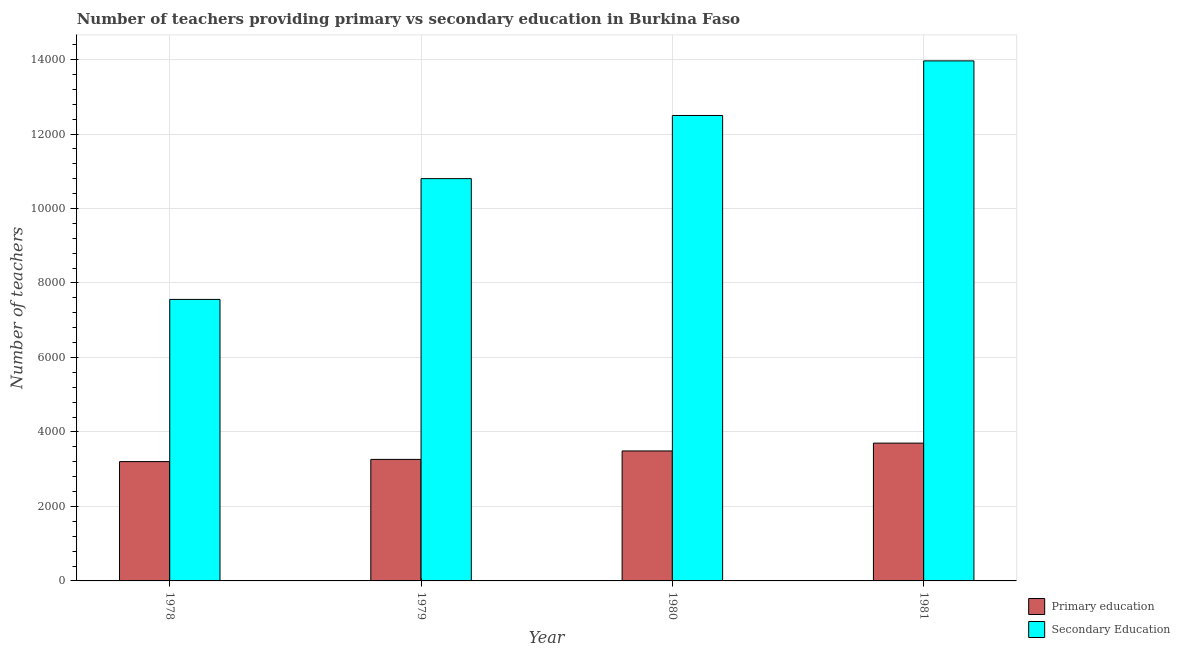Are the number of bars per tick equal to the number of legend labels?
Provide a succinct answer. Yes. How many bars are there on the 1st tick from the left?
Give a very brief answer. 2. What is the label of the 2nd group of bars from the left?
Your answer should be very brief. 1979. What is the number of secondary teachers in 1980?
Provide a succinct answer. 1.25e+04. Across all years, what is the maximum number of primary teachers?
Provide a succinct answer. 3700. Across all years, what is the minimum number of secondary teachers?
Keep it short and to the point. 7559. In which year was the number of primary teachers maximum?
Ensure brevity in your answer.  1981. In which year was the number of primary teachers minimum?
Offer a very short reply. 1978. What is the total number of primary teachers in the graph?
Make the answer very short. 1.37e+04. What is the difference between the number of primary teachers in 1980 and that in 1981?
Ensure brevity in your answer.  -210. What is the difference between the number of primary teachers in 1978 and the number of secondary teachers in 1981?
Ensure brevity in your answer.  -496. What is the average number of primary teachers per year?
Your response must be concise. 3414.25. What is the ratio of the number of secondary teachers in 1980 to that in 1981?
Your response must be concise. 0.9. Is the number of primary teachers in 1980 less than that in 1981?
Ensure brevity in your answer.  Yes. Is the difference between the number of primary teachers in 1980 and 1981 greater than the difference between the number of secondary teachers in 1980 and 1981?
Ensure brevity in your answer.  No. What is the difference between the highest and the second highest number of secondary teachers?
Provide a succinct answer. 1466. What is the difference between the highest and the lowest number of primary teachers?
Offer a terse response. 496. What does the 1st bar from the left in 1978 represents?
Your answer should be compact. Primary education. What does the 1st bar from the right in 1981 represents?
Offer a terse response. Secondary Education. How many bars are there?
Keep it short and to the point. 8. Are all the bars in the graph horizontal?
Provide a short and direct response. No. How many years are there in the graph?
Make the answer very short. 4. Are the values on the major ticks of Y-axis written in scientific E-notation?
Keep it short and to the point. No. What is the title of the graph?
Give a very brief answer. Number of teachers providing primary vs secondary education in Burkina Faso. Does "Net savings(excluding particulate emission damage)" appear as one of the legend labels in the graph?
Give a very brief answer. No. What is the label or title of the Y-axis?
Give a very brief answer. Number of teachers. What is the Number of teachers of Primary education in 1978?
Ensure brevity in your answer.  3204. What is the Number of teachers of Secondary Education in 1978?
Offer a very short reply. 7559. What is the Number of teachers in Primary education in 1979?
Ensure brevity in your answer.  3263. What is the Number of teachers in Secondary Education in 1979?
Your response must be concise. 1.08e+04. What is the Number of teachers in Primary education in 1980?
Offer a terse response. 3490. What is the Number of teachers of Secondary Education in 1980?
Your response must be concise. 1.25e+04. What is the Number of teachers of Primary education in 1981?
Give a very brief answer. 3700. What is the Number of teachers in Secondary Education in 1981?
Give a very brief answer. 1.40e+04. Across all years, what is the maximum Number of teachers in Primary education?
Give a very brief answer. 3700. Across all years, what is the maximum Number of teachers of Secondary Education?
Make the answer very short. 1.40e+04. Across all years, what is the minimum Number of teachers of Primary education?
Your response must be concise. 3204. Across all years, what is the minimum Number of teachers of Secondary Education?
Offer a terse response. 7559. What is the total Number of teachers in Primary education in the graph?
Your response must be concise. 1.37e+04. What is the total Number of teachers in Secondary Education in the graph?
Your answer should be very brief. 4.48e+04. What is the difference between the Number of teachers in Primary education in 1978 and that in 1979?
Ensure brevity in your answer.  -59. What is the difference between the Number of teachers in Secondary Education in 1978 and that in 1979?
Keep it short and to the point. -3243. What is the difference between the Number of teachers in Primary education in 1978 and that in 1980?
Your answer should be compact. -286. What is the difference between the Number of teachers of Secondary Education in 1978 and that in 1980?
Offer a terse response. -4939. What is the difference between the Number of teachers in Primary education in 1978 and that in 1981?
Make the answer very short. -496. What is the difference between the Number of teachers of Secondary Education in 1978 and that in 1981?
Give a very brief answer. -6405. What is the difference between the Number of teachers in Primary education in 1979 and that in 1980?
Offer a very short reply. -227. What is the difference between the Number of teachers in Secondary Education in 1979 and that in 1980?
Offer a very short reply. -1696. What is the difference between the Number of teachers of Primary education in 1979 and that in 1981?
Give a very brief answer. -437. What is the difference between the Number of teachers in Secondary Education in 1979 and that in 1981?
Your answer should be very brief. -3162. What is the difference between the Number of teachers of Primary education in 1980 and that in 1981?
Offer a very short reply. -210. What is the difference between the Number of teachers in Secondary Education in 1980 and that in 1981?
Provide a short and direct response. -1466. What is the difference between the Number of teachers in Primary education in 1978 and the Number of teachers in Secondary Education in 1979?
Offer a very short reply. -7598. What is the difference between the Number of teachers in Primary education in 1978 and the Number of teachers in Secondary Education in 1980?
Make the answer very short. -9294. What is the difference between the Number of teachers in Primary education in 1978 and the Number of teachers in Secondary Education in 1981?
Offer a terse response. -1.08e+04. What is the difference between the Number of teachers of Primary education in 1979 and the Number of teachers of Secondary Education in 1980?
Offer a terse response. -9235. What is the difference between the Number of teachers of Primary education in 1979 and the Number of teachers of Secondary Education in 1981?
Make the answer very short. -1.07e+04. What is the difference between the Number of teachers of Primary education in 1980 and the Number of teachers of Secondary Education in 1981?
Offer a very short reply. -1.05e+04. What is the average Number of teachers in Primary education per year?
Make the answer very short. 3414.25. What is the average Number of teachers of Secondary Education per year?
Your response must be concise. 1.12e+04. In the year 1978, what is the difference between the Number of teachers of Primary education and Number of teachers of Secondary Education?
Keep it short and to the point. -4355. In the year 1979, what is the difference between the Number of teachers of Primary education and Number of teachers of Secondary Education?
Keep it short and to the point. -7539. In the year 1980, what is the difference between the Number of teachers of Primary education and Number of teachers of Secondary Education?
Your response must be concise. -9008. In the year 1981, what is the difference between the Number of teachers in Primary education and Number of teachers in Secondary Education?
Ensure brevity in your answer.  -1.03e+04. What is the ratio of the Number of teachers in Primary education in 1978 to that in 1979?
Your answer should be compact. 0.98. What is the ratio of the Number of teachers in Secondary Education in 1978 to that in 1979?
Your answer should be compact. 0.7. What is the ratio of the Number of teachers in Primary education in 1978 to that in 1980?
Your response must be concise. 0.92. What is the ratio of the Number of teachers in Secondary Education in 1978 to that in 1980?
Your answer should be very brief. 0.6. What is the ratio of the Number of teachers of Primary education in 1978 to that in 1981?
Ensure brevity in your answer.  0.87. What is the ratio of the Number of teachers in Secondary Education in 1978 to that in 1981?
Give a very brief answer. 0.54. What is the ratio of the Number of teachers of Primary education in 1979 to that in 1980?
Make the answer very short. 0.94. What is the ratio of the Number of teachers of Secondary Education in 1979 to that in 1980?
Your answer should be very brief. 0.86. What is the ratio of the Number of teachers of Primary education in 1979 to that in 1981?
Provide a short and direct response. 0.88. What is the ratio of the Number of teachers of Secondary Education in 1979 to that in 1981?
Ensure brevity in your answer.  0.77. What is the ratio of the Number of teachers of Primary education in 1980 to that in 1981?
Your answer should be compact. 0.94. What is the ratio of the Number of teachers in Secondary Education in 1980 to that in 1981?
Your answer should be very brief. 0.9. What is the difference between the highest and the second highest Number of teachers of Primary education?
Provide a short and direct response. 210. What is the difference between the highest and the second highest Number of teachers of Secondary Education?
Your answer should be compact. 1466. What is the difference between the highest and the lowest Number of teachers in Primary education?
Make the answer very short. 496. What is the difference between the highest and the lowest Number of teachers in Secondary Education?
Your answer should be very brief. 6405. 